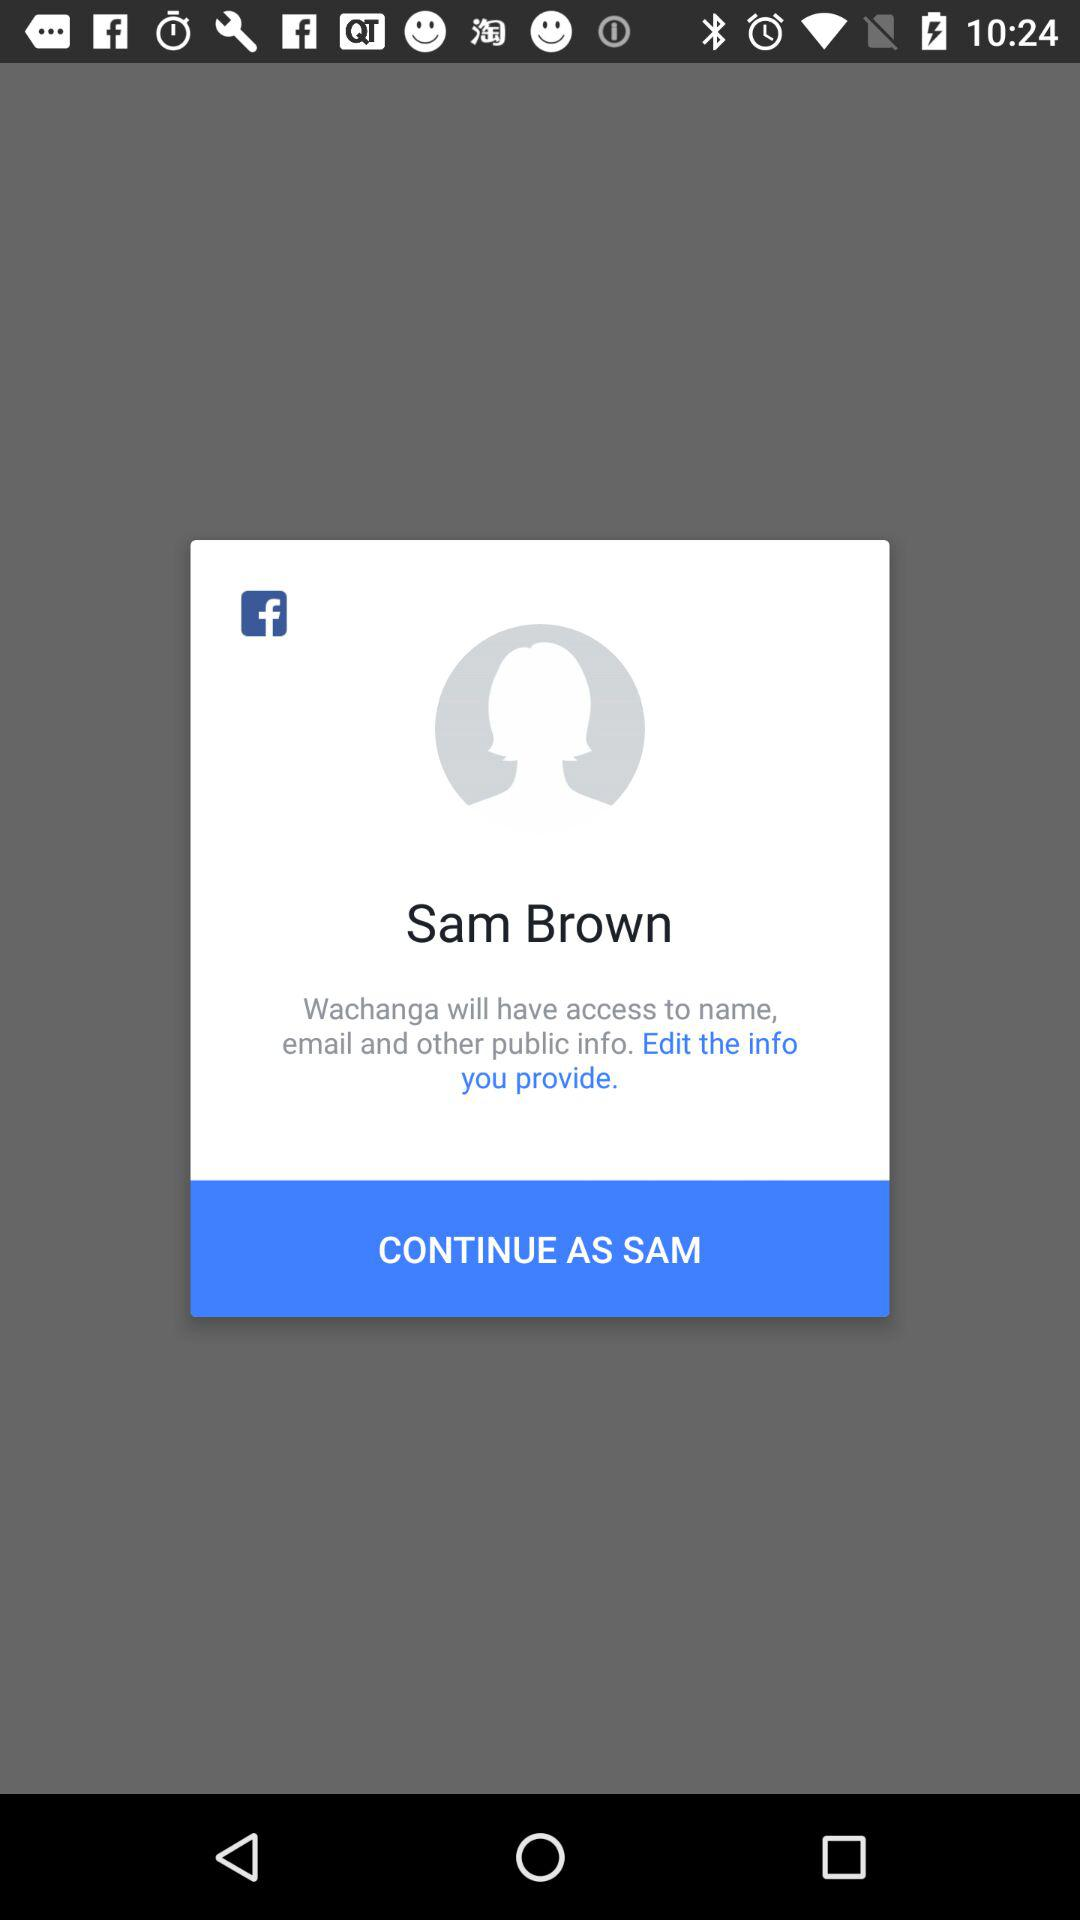What application is requesting access permission? The application is "Wachanga". 